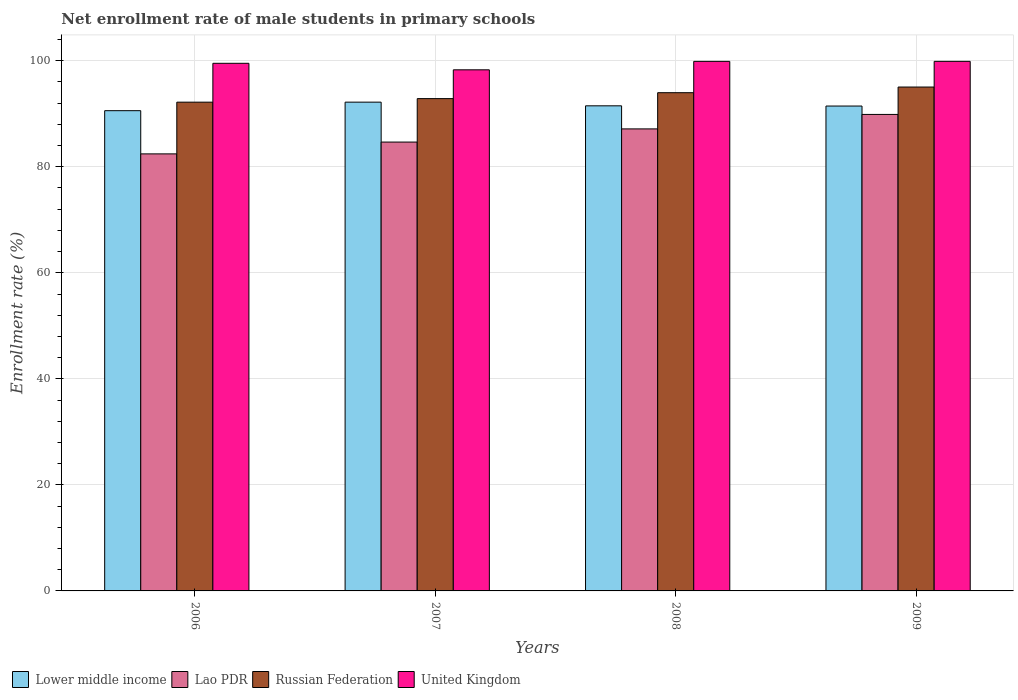Are the number of bars on each tick of the X-axis equal?
Your answer should be very brief. Yes. What is the net enrollment rate of male students in primary schools in Lao PDR in 2006?
Give a very brief answer. 82.43. Across all years, what is the maximum net enrollment rate of male students in primary schools in United Kingdom?
Give a very brief answer. 99.88. Across all years, what is the minimum net enrollment rate of male students in primary schools in Lower middle income?
Ensure brevity in your answer.  90.58. In which year was the net enrollment rate of male students in primary schools in Lower middle income minimum?
Ensure brevity in your answer.  2006. What is the total net enrollment rate of male students in primary schools in Russian Federation in the graph?
Provide a short and direct response. 374.04. What is the difference between the net enrollment rate of male students in primary schools in Russian Federation in 2007 and that in 2008?
Make the answer very short. -1.12. What is the difference between the net enrollment rate of male students in primary schools in United Kingdom in 2007 and the net enrollment rate of male students in primary schools in Lao PDR in 2008?
Keep it short and to the point. 11.14. What is the average net enrollment rate of male students in primary schools in Russian Federation per year?
Give a very brief answer. 93.51. In the year 2006, what is the difference between the net enrollment rate of male students in primary schools in United Kingdom and net enrollment rate of male students in primary schools in Russian Federation?
Your answer should be very brief. 7.33. What is the ratio of the net enrollment rate of male students in primary schools in Lao PDR in 2007 to that in 2009?
Keep it short and to the point. 0.94. Is the net enrollment rate of male students in primary schools in United Kingdom in 2008 less than that in 2009?
Provide a short and direct response. Yes. Is the difference between the net enrollment rate of male students in primary schools in United Kingdom in 2007 and 2009 greater than the difference between the net enrollment rate of male students in primary schools in Russian Federation in 2007 and 2009?
Offer a terse response. Yes. What is the difference between the highest and the second highest net enrollment rate of male students in primary schools in Russian Federation?
Provide a succinct answer. 1.06. What is the difference between the highest and the lowest net enrollment rate of male students in primary schools in Russian Federation?
Provide a short and direct response. 2.85. In how many years, is the net enrollment rate of male students in primary schools in Lower middle income greater than the average net enrollment rate of male students in primary schools in Lower middle income taken over all years?
Provide a succinct answer. 3. Is the sum of the net enrollment rate of male students in primary schools in Lao PDR in 2006 and 2008 greater than the maximum net enrollment rate of male students in primary schools in United Kingdom across all years?
Offer a very short reply. Yes. What does the 1st bar from the left in 2009 represents?
Provide a short and direct response. Lower middle income. What does the 2nd bar from the right in 2007 represents?
Your answer should be compact. Russian Federation. Is it the case that in every year, the sum of the net enrollment rate of male students in primary schools in United Kingdom and net enrollment rate of male students in primary schools in Russian Federation is greater than the net enrollment rate of male students in primary schools in Lao PDR?
Keep it short and to the point. Yes. Are all the bars in the graph horizontal?
Your answer should be very brief. No. How many years are there in the graph?
Keep it short and to the point. 4. Does the graph contain grids?
Keep it short and to the point. Yes. Where does the legend appear in the graph?
Your response must be concise. Bottom left. How many legend labels are there?
Provide a succinct answer. 4. What is the title of the graph?
Provide a succinct answer. Net enrollment rate of male students in primary schools. Does "East Asia (all income levels)" appear as one of the legend labels in the graph?
Provide a short and direct response. No. What is the label or title of the Y-axis?
Your answer should be very brief. Enrollment rate (%). What is the Enrollment rate (%) in Lower middle income in 2006?
Your response must be concise. 90.58. What is the Enrollment rate (%) in Lao PDR in 2006?
Your answer should be compact. 82.43. What is the Enrollment rate (%) of Russian Federation in 2006?
Offer a very short reply. 92.18. What is the Enrollment rate (%) in United Kingdom in 2006?
Offer a terse response. 99.51. What is the Enrollment rate (%) in Lower middle income in 2007?
Provide a short and direct response. 92.19. What is the Enrollment rate (%) in Lao PDR in 2007?
Offer a terse response. 84.66. What is the Enrollment rate (%) of Russian Federation in 2007?
Your answer should be compact. 92.85. What is the Enrollment rate (%) of United Kingdom in 2007?
Your answer should be very brief. 98.28. What is the Enrollment rate (%) of Lower middle income in 2008?
Offer a very short reply. 91.49. What is the Enrollment rate (%) of Lao PDR in 2008?
Make the answer very short. 87.14. What is the Enrollment rate (%) in Russian Federation in 2008?
Your answer should be very brief. 93.97. What is the Enrollment rate (%) in United Kingdom in 2008?
Provide a succinct answer. 99.88. What is the Enrollment rate (%) of Lower middle income in 2009?
Your answer should be very brief. 91.45. What is the Enrollment rate (%) in Lao PDR in 2009?
Make the answer very short. 89.87. What is the Enrollment rate (%) in Russian Federation in 2009?
Provide a short and direct response. 95.03. What is the Enrollment rate (%) in United Kingdom in 2009?
Your response must be concise. 99.88. Across all years, what is the maximum Enrollment rate (%) in Lower middle income?
Offer a very short reply. 92.19. Across all years, what is the maximum Enrollment rate (%) in Lao PDR?
Provide a succinct answer. 89.87. Across all years, what is the maximum Enrollment rate (%) of Russian Federation?
Your answer should be compact. 95.03. Across all years, what is the maximum Enrollment rate (%) in United Kingdom?
Offer a very short reply. 99.88. Across all years, what is the minimum Enrollment rate (%) of Lower middle income?
Offer a very short reply. 90.58. Across all years, what is the minimum Enrollment rate (%) of Lao PDR?
Provide a short and direct response. 82.43. Across all years, what is the minimum Enrollment rate (%) in Russian Federation?
Keep it short and to the point. 92.18. Across all years, what is the minimum Enrollment rate (%) of United Kingdom?
Offer a terse response. 98.28. What is the total Enrollment rate (%) of Lower middle income in the graph?
Provide a short and direct response. 365.71. What is the total Enrollment rate (%) in Lao PDR in the graph?
Offer a terse response. 344.1. What is the total Enrollment rate (%) of Russian Federation in the graph?
Make the answer very short. 374.04. What is the total Enrollment rate (%) of United Kingdom in the graph?
Your response must be concise. 397.55. What is the difference between the Enrollment rate (%) of Lower middle income in 2006 and that in 2007?
Give a very brief answer. -1.61. What is the difference between the Enrollment rate (%) of Lao PDR in 2006 and that in 2007?
Offer a terse response. -2.23. What is the difference between the Enrollment rate (%) in Russian Federation in 2006 and that in 2007?
Offer a terse response. -0.67. What is the difference between the Enrollment rate (%) in United Kingdom in 2006 and that in 2007?
Your response must be concise. 1.23. What is the difference between the Enrollment rate (%) in Lower middle income in 2006 and that in 2008?
Your answer should be very brief. -0.92. What is the difference between the Enrollment rate (%) in Lao PDR in 2006 and that in 2008?
Make the answer very short. -4.71. What is the difference between the Enrollment rate (%) of Russian Federation in 2006 and that in 2008?
Your answer should be very brief. -1.79. What is the difference between the Enrollment rate (%) of United Kingdom in 2006 and that in 2008?
Provide a succinct answer. -0.36. What is the difference between the Enrollment rate (%) in Lower middle income in 2006 and that in 2009?
Your response must be concise. -0.88. What is the difference between the Enrollment rate (%) of Lao PDR in 2006 and that in 2009?
Ensure brevity in your answer.  -7.44. What is the difference between the Enrollment rate (%) of Russian Federation in 2006 and that in 2009?
Make the answer very short. -2.85. What is the difference between the Enrollment rate (%) of United Kingdom in 2006 and that in 2009?
Provide a short and direct response. -0.37. What is the difference between the Enrollment rate (%) of Lower middle income in 2007 and that in 2008?
Offer a very short reply. 0.69. What is the difference between the Enrollment rate (%) of Lao PDR in 2007 and that in 2008?
Offer a very short reply. -2.48. What is the difference between the Enrollment rate (%) of Russian Federation in 2007 and that in 2008?
Offer a terse response. -1.12. What is the difference between the Enrollment rate (%) of United Kingdom in 2007 and that in 2008?
Give a very brief answer. -1.59. What is the difference between the Enrollment rate (%) in Lower middle income in 2007 and that in 2009?
Ensure brevity in your answer.  0.73. What is the difference between the Enrollment rate (%) in Lao PDR in 2007 and that in 2009?
Offer a terse response. -5.21. What is the difference between the Enrollment rate (%) in Russian Federation in 2007 and that in 2009?
Provide a succinct answer. -2.18. What is the difference between the Enrollment rate (%) of United Kingdom in 2007 and that in 2009?
Offer a very short reply. -1.6. What is the difference between the Enrollment rate (%) of Lower middle income in 2008 and that in 2009?
Provide a short and direct response. 0.04. What is the difference between the Enrollment rate (%) of Lao PDR in 2008 and that in 2009?
Offer a very short reply. -2.73. What is the difference between the Enrollment rate (%) in Russian Federation in 2008 and that in 2009?
Make the answer very short. -1.06. What is the difference between the Enrollment rate (%) in United Kingdom in 2008 and that in 2009?
Provide a succinct answer. -0. What is the difference between the Enrollment rate (%) in Lower middle income in 2006 and the Enrollment rate (%) in Lao PDR in 2007?
Provide a short and direct response. 5.92. What is the difference between the Enrollment rate (%) in Lower middle income in 2006 and the Enrollment rate (%) in Russian Federation in 2007?
Make the answer very short. -2.28. What is the difference between the Enrollment rate (%) in Lower middle income in 2006 and the Enrollment rate (%) in United Kingdom in 2007?
Give a very brief answer. -7.71. What is the difference between the Enrollment rate (%) of Lao PDR in 2006 and the Enrollment rate (%) of Russian Federation in 2007?
Provide a succinct answer. -10.42. What is the difference between the Enrollment rate (%) of Lao PDR in 2006 and the Enrollment rate (%) of United Kingdom in 2007?
Keep it short and to the point. -15.86. What is the difference between the Enrollment rate (%) of Russian Federation in 2006 and the Enrollment rate (%) of United Kingdom in 2007?
Your answer should be compact. -6.1. What is the difference between the Enrollment rate (%) in Lower middle income in 2006 and the Enrollment rate (%) in Lao PDR in 2008?
Your response must be concise. 3.43. What is the difference between the Enrollment rate (%) in Lower middle income in 2006 and the Enrollment rate (%) in Russian Federation in 2008?
Offer a terse response. -3.39. What is the difference between the Enrollment rate (%) of Lower middle income in 2006 and the Enrollment rate (%) of United Kingdom in 2008?
Make the answer very short. -9.3. What is the difference between the Enrollment rate (%) in Lao PDR in 2006 and the Enrollment rate (%) in Russian Federation in 2008?
Provide a succinct answer. -11.54. What is the difference between the Enrollment rate (%) of Lao PDR in 2006 and the Enrollment rate (%) of United Kingdom in 2008?
Your response must be concise. -17.45. What is the difference between the Enrollment rate (%) of Russian Federation in 2006 and the Enrollment rate (%) of United Kingdom in 2008?
Your answer should be very brief. -7.69. What is the difference between the Enrollment rate (%) in Lower middle income in 2006 and the Enrollment rate (%) in Lao PDR in 2009?
Keep it short and to the point. 0.71. What is the difference between the Enrollment rate (%) of Lower middle income in 2006 and the Enrollment rate (%) of Russian Federation in 2009?
Offer a terse response. -4.46. What is the difference between the Enrollment rate (%) in Lower middle income in 2006 and the Enrollment rate (%) in United Kingdom in 2009?
Your answer should be very brief. -9.3. What is the difference between the Enrollment rate (%) in Lao PDR in 2006 and the Enrollment rate (%) in Russian Federation in 2009?
Ensure brevity in your answer.  -12.61. What is the difference between the Enrollment rate (%) in Lao PDR in 2006 and the Enrollment rate (%) in United Kingdom in 2009?
Give a very brief answer. -17.45. What is the difference between the Enrollment rate (%) in Russian Federation in 2006 and the Enrollment rate (%) in United Kingdom in 2009?
Provide a succinct answer. -7.7. What is the difference between the Enrollment rate (%) of Lower middle income in 2007 and the Enrollment rate (%) of Lao PDR in 2008?
Your answer should be very brief. 5.04. What is the difference between the Enrollment rate (%) of Lower middle income in 2007 and the Enrollment rate (%) of Russian Federation in 2008?
Give a very brief answer. -1.78. What is the difference between the Enrollment rate (%) in Lower middle income in 2007 and the Enrollment rate (%) in United Kingdom in 2008?
Offer a very short reply. -7.69. What is the difference between the Enrollment rate (%) of Lao PDR in 2007 and the Enrollment rate (%) of Russian Federation in 2008?
Offer a terse response. -9.31. What is the difference between the Enrollment rate (%) of Lao PDR in 2007 and the Enrollment rate (%) of United Kingdom in 2008?
Your answer should be compact. -15.22. What is the difference between the Enrollment rate (%) in Russian Federation in 2007 and the Enrollment rate (%) in United Kingdom in 2008?
Keep it short and to the point. -7.02. What is the difference between the Enrollment rate (%) of Lower middle income in 2007 and the Enrollment rate (%) of Lao PDR in 2009?
Give a very brief answer. 2.32. What is the difference between the Enrollment rate (%) in Lower middle income in 2007 and the Enrollment rate (%) in Russian Federation in 2009?
Your answer should be very brief. -2.85. What is the difference between the Enrollment rate (%) in Lower middle income in 2007 and the Enrollment rate (%) in United Kingdom in 2009?
Your answer should be very brief. -7.69. What is the difference between the Enrollment rate (%) of Lao PDR in 2007 and the Enrollment rate (%) of Russian Federation in 2009?
Give a very brief answer. -10.38. What is the difference between the Enrollment rate (%) of Lao PDR in 2007 and the Enrollment rate (%) of United Kingdom in 2009?
Your answer should be compact. -15.22. What is the difference between the Enrollment rate (%) of Russian Federation in 2007 and the Enrollment rate (%) of United Kingdom in 2009?
Offer a very short reply. -7.03. What is the difference between the Enrollment rate (%) of Lower middle income in 2008 and the Enrollment rate (%) of Lao PDR in 2009?
Provide a succinct answer. 1.62. What is the difference between the Enrollment rate (%) in Lower middle income in 2008 and the Enrollment rate (%) in Russian Federation in 2009?
Your answer should be very brief. -3.54. What is the difference between the Enrollment rate (%) in Lower middle income in 2008 and the Enrollment rate (%) in United Kingdom in 2009?
Your answer should be compact. -8.39. What is the difference between the Enrollment rate (%) in Lao PDR in 2008 and the Enrollment rate (%) in Russian Federation in 2009?
Provide a succinct answer. -7.89. What is the difference between the Enrollment rate (%) of Lao PDR in 2008 and the Enrollment rate (%) of United Kingdom in 2009?
Your response must be concise. -12.74. What is the difference between the Enrollment rate (%) of Russian Federation in 2008 and the Enrollment rate (%) of United Kingdom in 2009?
Your response must be concise. -5.91. What is the average Enrollment rate (%) in Lower middle income per year?
Offer a very short reply. 91.43. What is the average Enrollment rate (%) of Lao PDR per year?
Your answer should be compact. 86.02. What is the average Enrollment rate (%) of Russian Federation per year?
Offer a very short reply. 93.51. What is the average Enrollment rate (%) in United Kingdom per year?
Offer a terse response. 99.39. In the year 2006, what is the difference between the Enrollment rate (%) in Lower middle income and Enrollment rate (%) in Lao PDR?
Your answer should be compact. 8.15. In the year 2006, what is the difference between the Enrollment rate (%) in Lower middle income and Enrollment rate (%) in Russian Federation?
Provide a short and direct response. -1.61. In the year 2006, what is the difference between the Enrollment rate (%) of Lower middle income and Enrollment rate (%) of United Kingdom?
Offer a terse response. -8.94. In the year 2006, what is the difference between the Enrollment rate (%) of Lao PDR and Enrollment rate (%) of Russian Federation?
Your answer should be compact. -9.76. In the year 2006, what is the difference between the Enrollment rate (%) of Lao PDR and Enrollment rate (%) of United Kingdom?
Your answer should be very brief. -17.08. In the year 2006, what is the difference between the Enrollment rate (%) in Russian Federation and Enrollment rate (%) in United Kingdom?
Make the answer very short. -7.33. In the year 2007, what is the difference between the Enrollment rate (%) of Lower middle income and Enrollment rate (%) of Lao PDR?
Offer a terse response. 7.53. In the year 2007, what is the difference between the Enrollment rate (%) of Lower middle income and Enrollment rate (%) of Russian Federation?
Your response must be concise. -0.67. In the year 2007, what is the difference between the Enrollment rate (%) of Lower middle income and Enrollment rate (%) of United Kingdom?
Your answer should be very brief. -6.1. In the year 2007, what is the difference between the Enrollment rate (%) in Lao PDR and Enrollment rate (%) in Russian Federation?
Make the answer very short. -8.19. In the year 2007, what is the difference between the Enrollment rate (%) of Lao PDR and Enrollment rate (%) of United Kingdom?
Make the answer very short. -13.63. In the year 2007, what is the difference between the Enrollment rate (%) in Russian Federation and Enrollment rate (%) in United Kingdom?
Your answer should be very brief. -5.43. In the year 2008, what is the difference between the Enrollment rate (%) in Lower middle income and Enrollment rate (%) in Lao PDR?
Your answer should be very brief. 4.35. In the year 2008, what is the difference between the Enrollment rate (%) in Lower middle income and Enrollment rate (%) in Russian Federation?
Provide a succinct answer. -2.48. In the year 2008, what is the difference between the Enrollment rate (%) in Lower middle income and Enrollment rate (%) in United Kingdom?
Your answer should be compact. -8.38. In the year 2008, what is the difference between the Enrollment rate (%) of Lao PDR and Enrollment rate (%) of Russian Federation?
Offer a terse response. -6.83. In the year 2008, what is the difference between the Enrollment rate (%) in Lao PDR and Enrollment rate (%) in United Kingdom?
Offer a terse response. -12.74. In the year 2008, what is the difference between the Enrollment rate (%) in Russian Federation and Enrollment rate (%) in United Kingdom?
Provide a succinct answer. -5.91. In the year 2009, what is the difference between the Enrollment rate (%) in Lower middle income and Enrollment rate (%) in Lao PDR?
Offer a terse response. 1.58. In the year 2009, what is the difference between the Enrollment rate (%) in Lower middle income and Enrollment rate (%) in Russian Federation?
Offer a very short reply. -3.58. In the year 2009, what is the difference between the Enrollment rate (%) of Lower middle income and Enrollment rate (%) of United Kingdom?
Ensure brevity in your answer.  -8.43. In the year 2009, what is the difference between the Enrollment rate (%) of Lao PDR and Enrollment rate (%) of Russian Federation?
Ensure brevity in your answer.  -5.16. In the year 2009, what is the difference between the Enrollment rate (%) in Lao PDR and Enrollment rate (%) in United Kingdom?
Your answer should be compact. -10.01. In the year 2009, what is the difference between the Enrollment rate (%) of Russian Federation and Enrollment rate (%) of United Kingdom?
Provide a succinct answer. -4.85. What is the ratio of the Enrollment rate (%) in Lower middle income in 2006 to that in 2007?
Provide a succinct answer. 0.98. What is the ratio of the Enrollment rate (%) of Lao PDR in 2006 to that in 2007?
Ensure brevity in your answer.  0.97. What is the ratio of the Enrollment rate (%) of Russian Federation in 2006 to that in 2007?
Your answer should be compact. 0.99. What is the ratio of the Enrollment rate (%) in United Kingdom in 2006 to that in 2007?
Keep it short and to the point. 1.01. What is the ratio of the Enrollment rate (%) in Lower middle income in 2006 to that in 2008?
Your answer should be compact. 0.99. What is the ratio of the Enrollment rate (%) in Lao PDR in 2006 to that in 2008?
Your response must be concise. 0.95. What is the ratio of the Enrollment rate (%) in Russian Federation in 2006 to that in 2008?
Give a very brief answer. 0.98. What is the ratio of the Enrollment rate (%) of United Kingdom in 2006 to that in 2008?
Make the answer very short. 1. What is the ratio of the Enrollment rate (%) of Lower middle income in 2006 to that in 2009?
Your answer should be very brief. 0.99. What is the ratio of the Enrollment rate (%) of Lao PDR in 2006 to that in 2009?
Your response must be concise. 0.92. What is the ratio of the Enrollment rate (%) in Russian Federation in 2006 to that in 2009?
Keep it short and to the point. 0.97. What is the ratio of the Enrollment rate (%) in United Kingdom in 2006 to that in 2009?
Provide a succinct answer. 1. What is the ratio of the Enrollment rate (%) in Lower middle income in 2007 to that in 2008?
Keep it short and to the point. 1.01. What is the ratio of the Enrollment rate (%) in Lao PDR in 2007 to that in 2008?
Give a very brief answer. 0.97. What is the ratio of the Enrollment rate (%) in Russian Federation in 2007 to that in 2008?
Keep it short and to the point. 0.99. What is the ratio of the Enrollment rate (%) in United Kingdom in 2007 to that in 2008?
Your answer should be very brief. 0.98. What is the ratio of the Enrollment rate (%) in Lao PDR in 2007 to that in 2009?
Provide a succinct answer. 0.94. What is the ratio of the Enrollment rate (%) of Lao PDR in 2008 to that in 2009?
Make the answer very short. 0.97. What is the difference between the highest and the second highest Enrollment rate (%) of Lower middle income?
Your response must be concise. 0.69. What is the difference between the highest and the second highest Enrollment rate (%) of Lao PDR?
Provide a short and direct response. 2.73. What is the difference between the highest and the second highest Enrollment rate (%) in Russian Federation?
Provide a succinct answer. 1.06. What is the difference between the highest and the second highest Enrollment rate (%) of United Kingdom?
Provide a short and direct response. 0. What is the difference between the highest and the lowest Enrollment rate (%) in Lower middle income?
Offer a terse response. 1.61. What is the difference between the highest and the lowest Enrollment rate (%) of Lao PDR?
Ensure brevity in your answer.  7.44. What is the difference between the highest and the lowest Enrollment rate (%) in Russian Federation?
Provide a short and direct response. 2.85. What is the difference between the highest and the lowest Enrollment rate (%) in United Kingdom?
Make the answer very short. 1.6. 